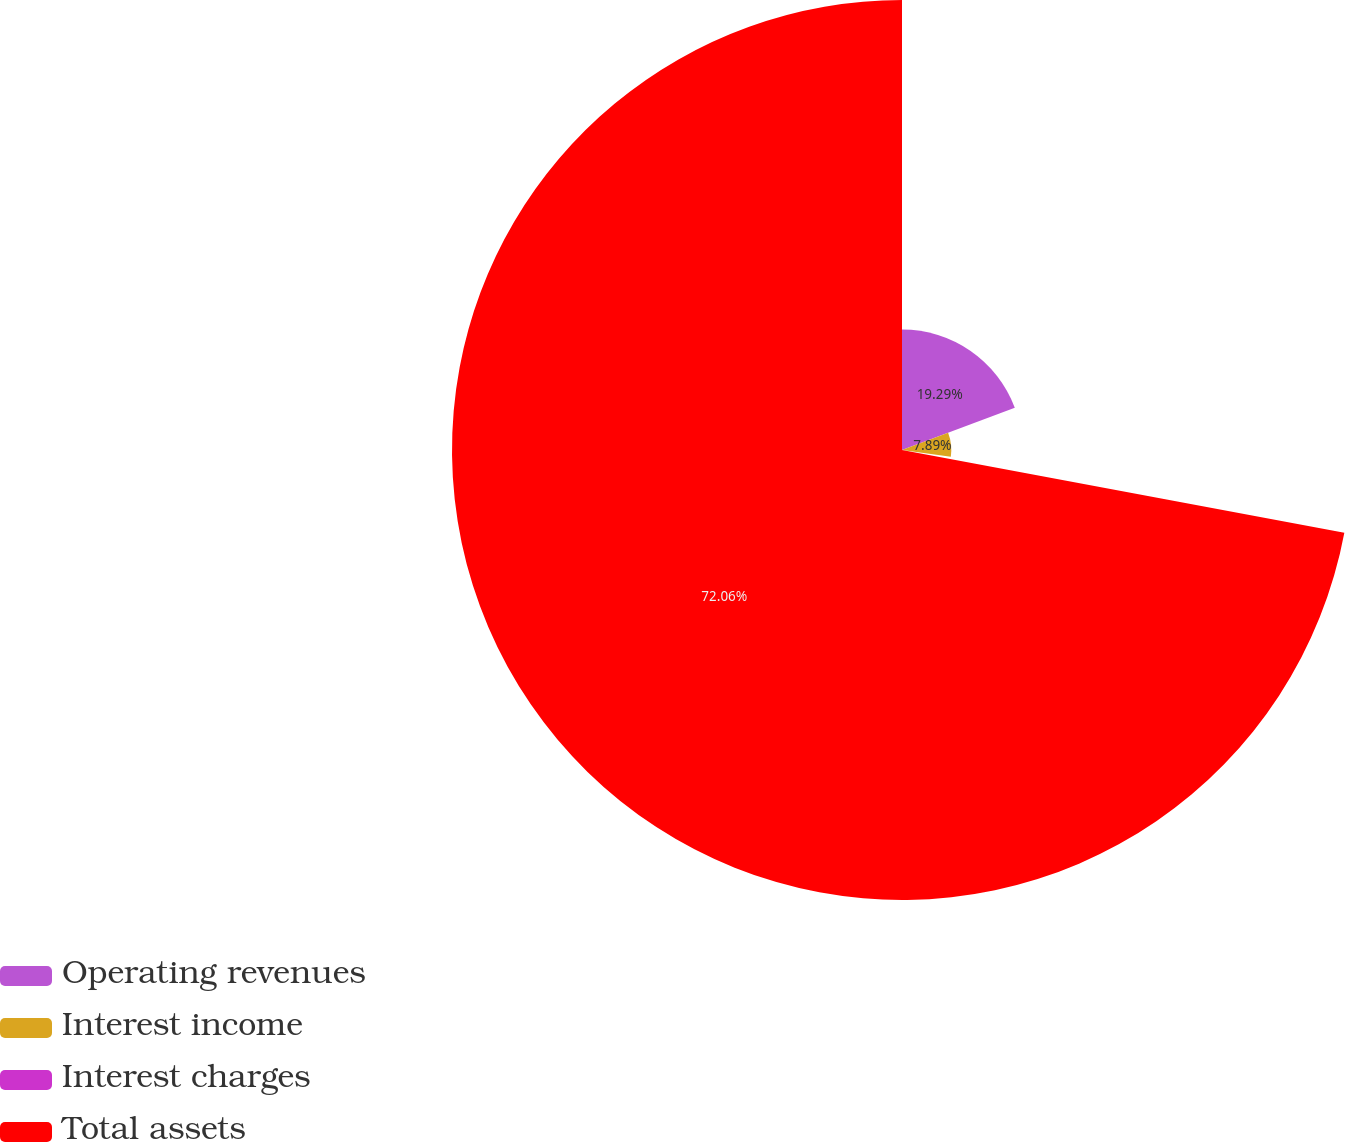Convert chart. <chart><loc_0><loc_0><loc_500><loc_500><pie_chart><fcel>Operating revenues<fcel>Interest income<fcel>Interest charges<fcel>Total assets<nl><fcel>19.29%<fcel>7.89%<fcel>0.76%<fcel>72.06%<nl></chart> 